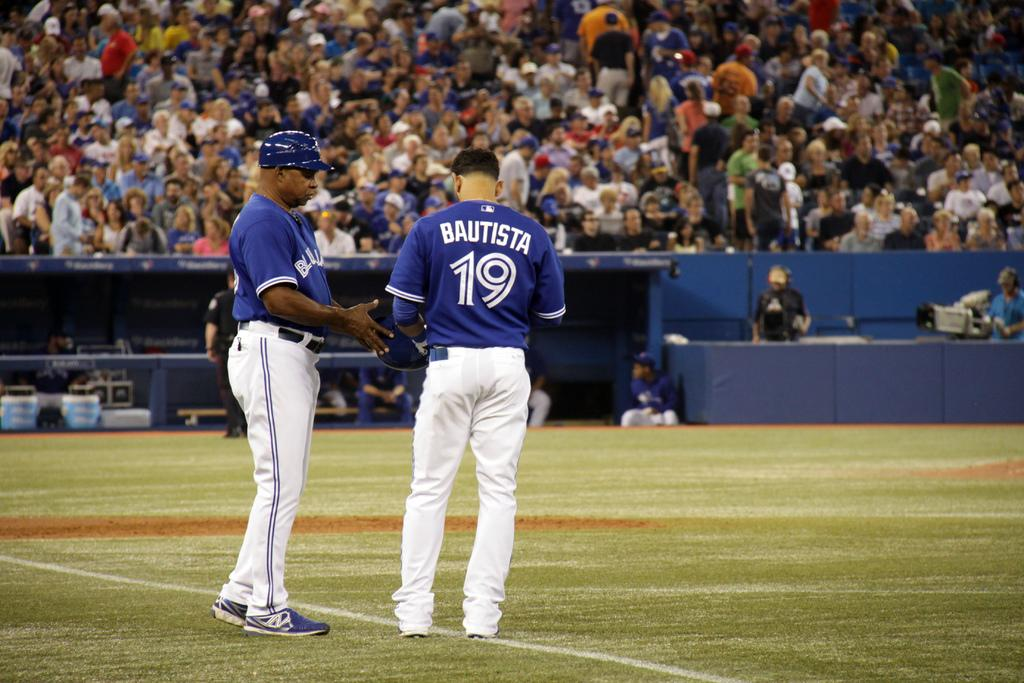<image>
Relay a brief, clear account of the picture shown. A ball player named Bautista wears the number 19 uniform. 